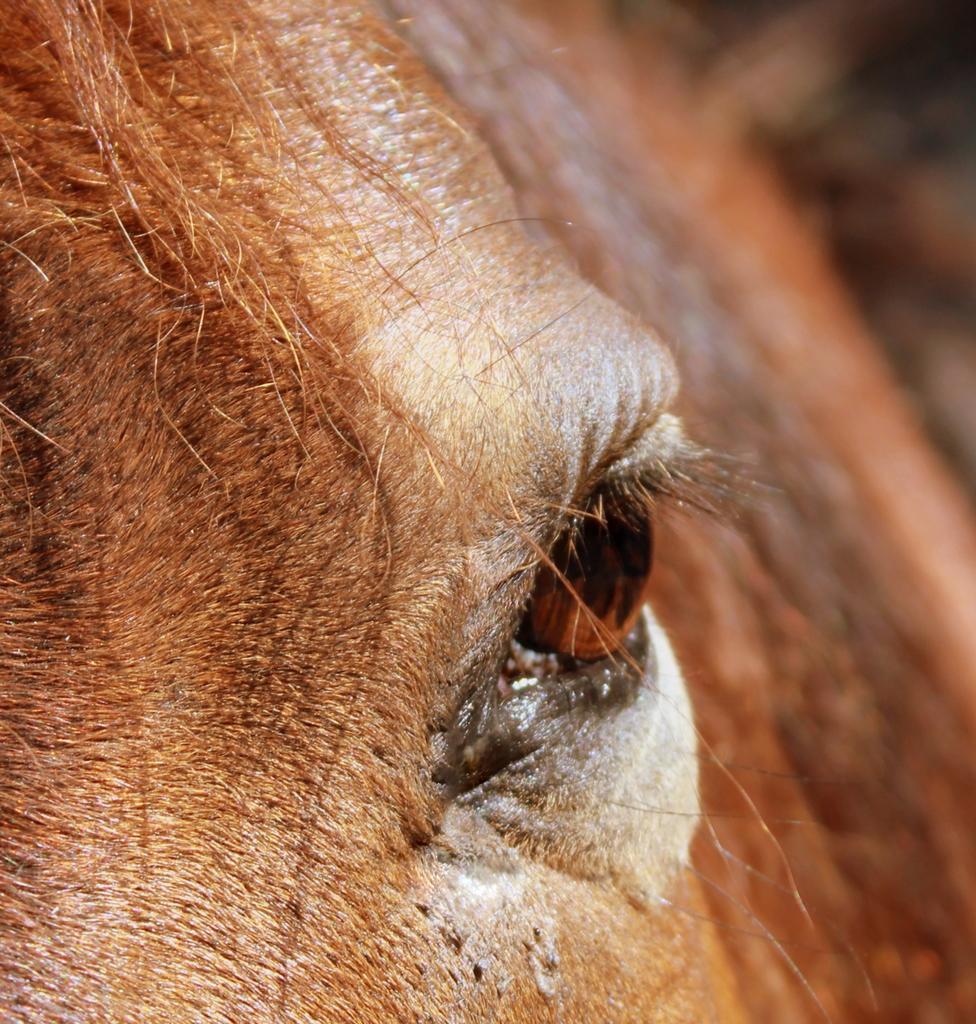Please provide a concise description of this image. In this image, in the middle, we can see an eye of an animal. On the left side, we can see the head of an animal. 